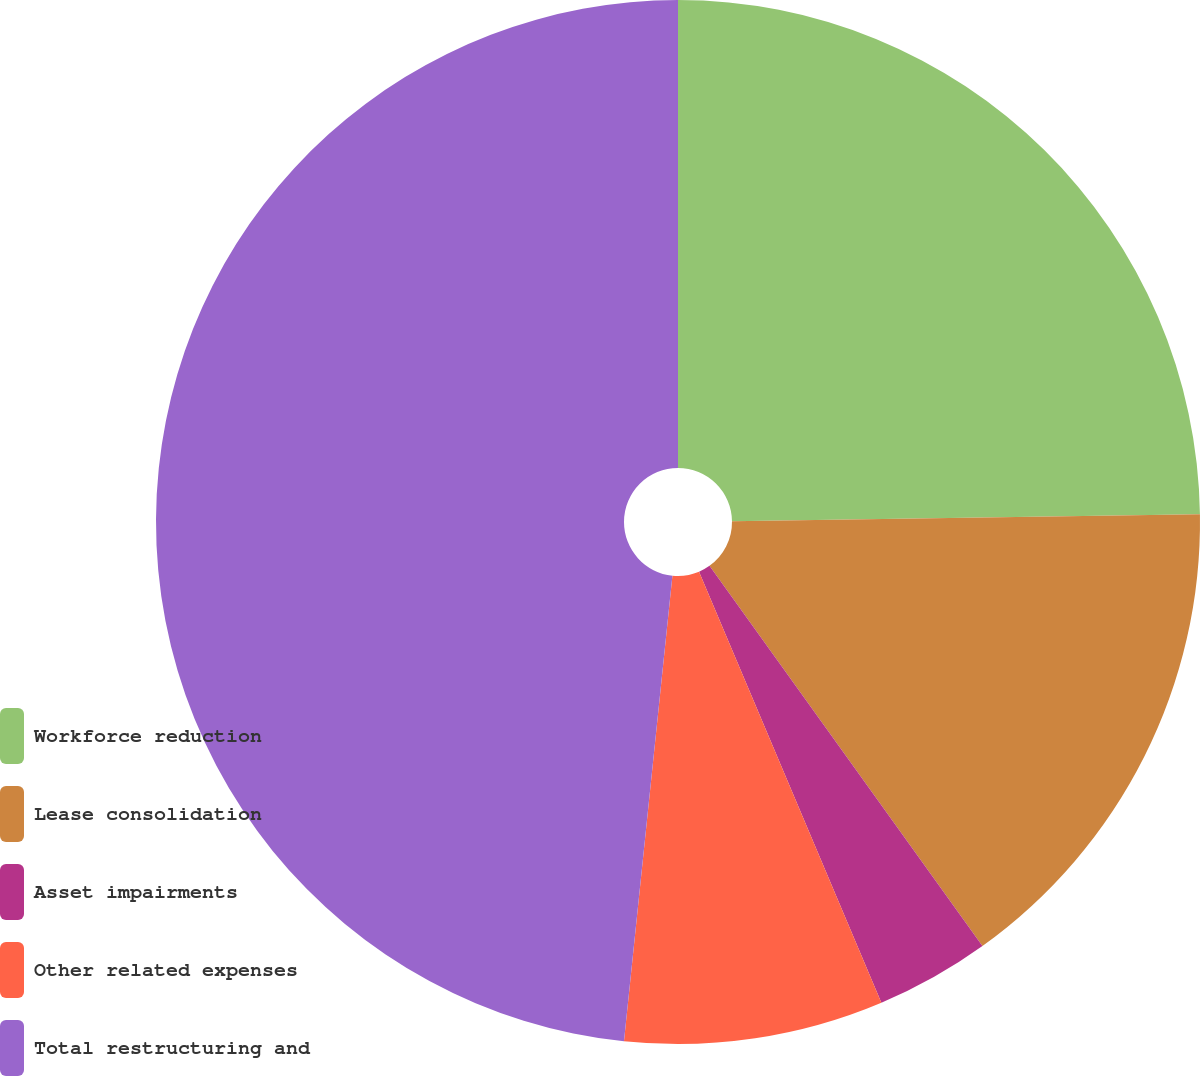Convert chart. <chart><loc_0><loc_0><loc_500><loc_500><pie_chart><fcel>Workforce reduction<fcel>Lease consolidation<fcel>Asset impairments<fcel>Other related expenses<fcel>Total restructuring and<nl><fcel>24.76%<fcel>15.33%<fcel>3.54%<fcel>8.02%<fcel>48.35%<nl></chart> 